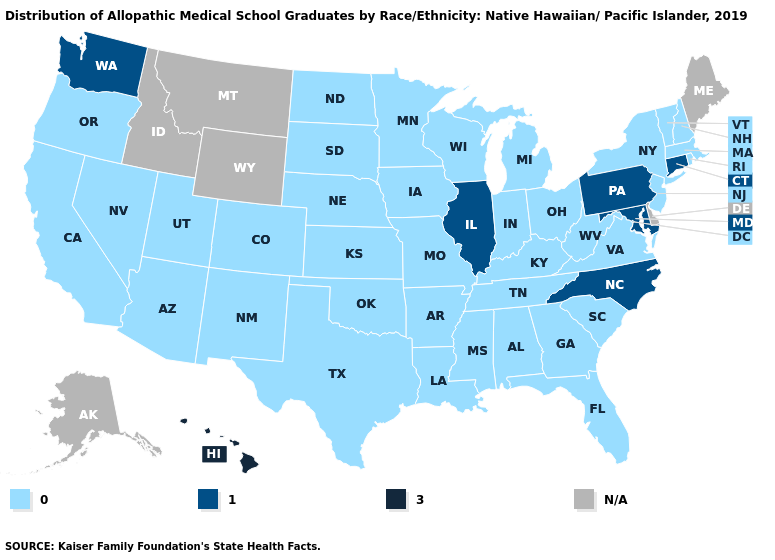Name the states that have a value in the range N/A?
Short answer required. Alaska, Delaware, Idaho, Maine, Montana, Wyoming. What is the highest value in states that border Missouri?
Short answer required. 1.0. What is the value of Nebraska?
Answer briefly. 0.0. What is the value of Wyoming?
Answer briefly. N/A. Name the states that have a value in the range 3.0?
Give a very brief answer. Hawaii. Name the states that have a value in the range 1.0?
Write a very short answer. Connecticut, Illinois, Maryland, North Carolina, Pennsylvania, Washington. Does Nebraska have the lowest value in the USA?
Keep it brief. Yes. Which states have the highest value in the USA?
Short answer required. Hawaii. Does Hawaii have the highest value in the USA?
Concise answer only. Yes. Name the states that have a value in the range 3.0?
Write a very short answer. Hawaii. What is the value of Idaho?
Keep it brief. N/A. Name the states that have a value in the range 1.0?
Answer briefly. Connecticut, Illinois, Maryland, North Carolina, Pennsylvania, Washington. Does the first symbol in the legend represent the smallest category?
Write a very short answer. Yes. 